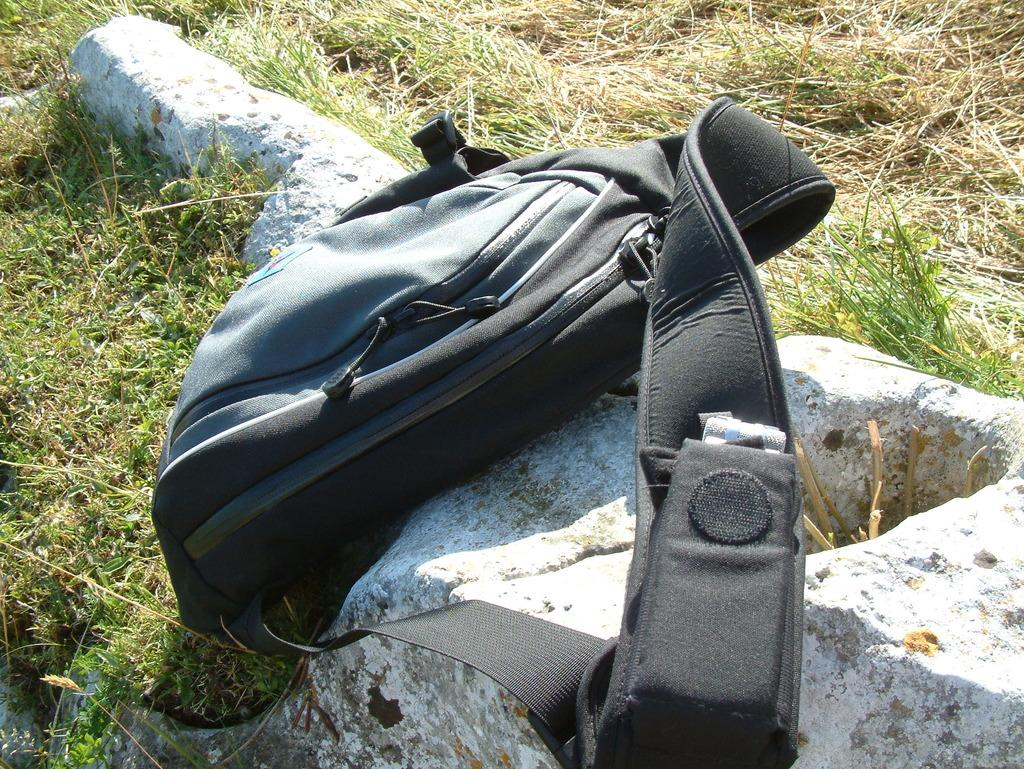What object is visible in the image? There is a bag in the image. Where is the bag located? The bag is placed on a rock. What can be observed about the ground in the image? The ground is covered in greenery. Is there a river flowing near the bag in the image? There is no river visible in the image; it only shows a bag placed on a rock with greenery on the ground. 